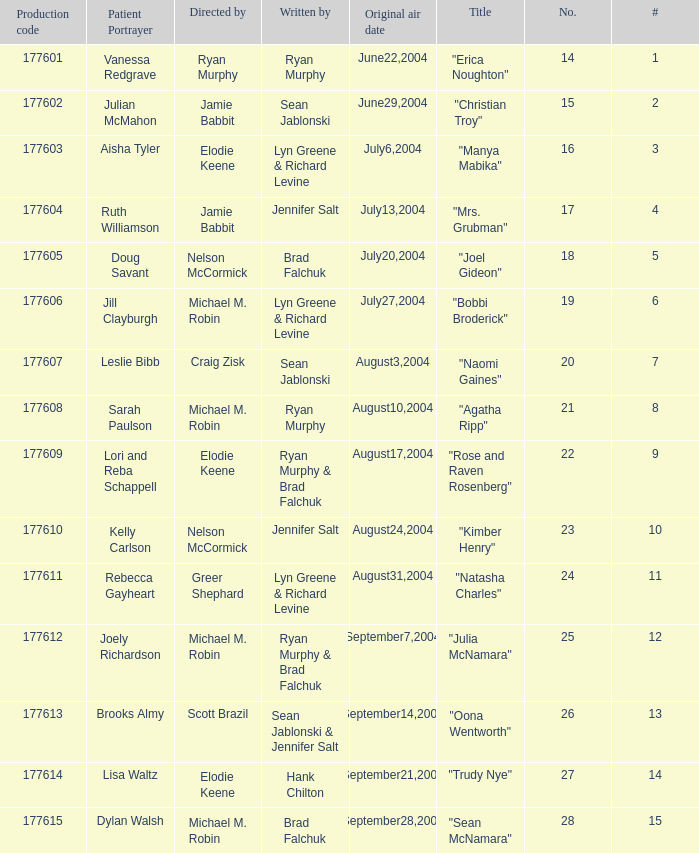What numbered episode is titled "naomi gaines"? 20.0. 